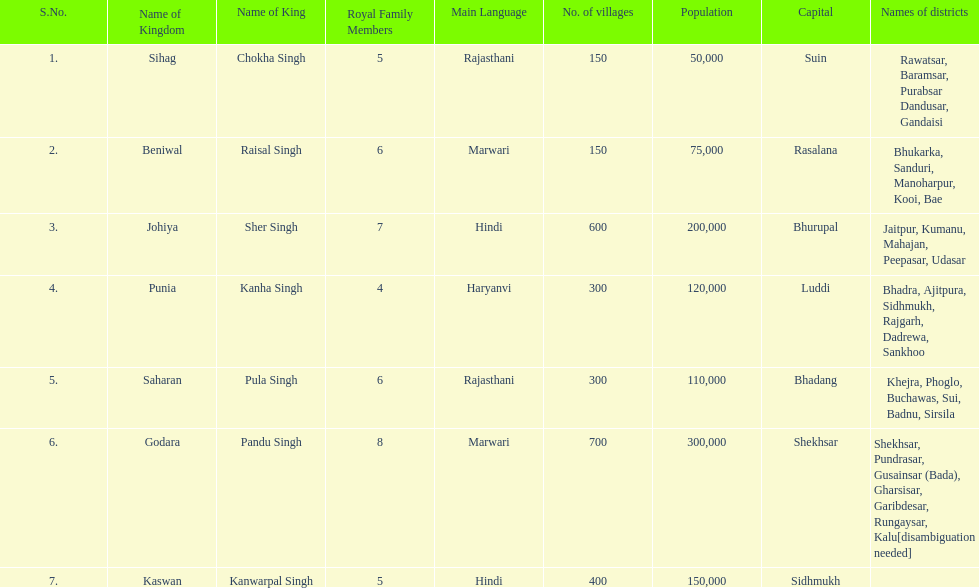What are the number of villages johiya has according to this chart? 600. 